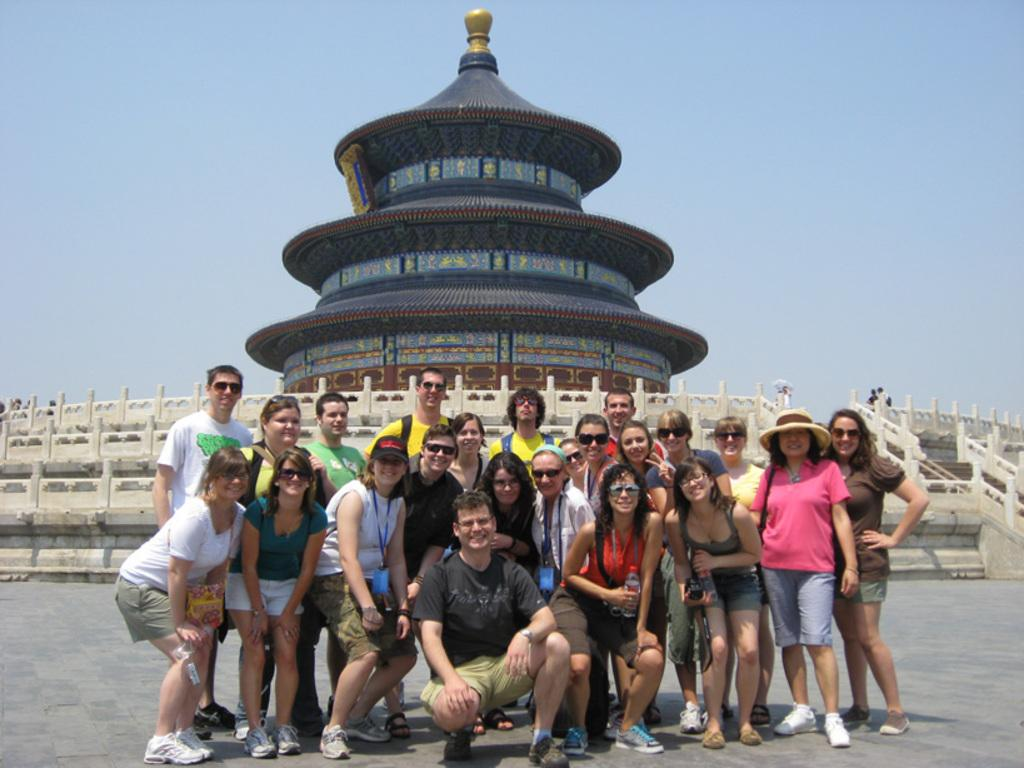What are the people in the image doing? The people in the image are sitting and standing on the floor. What is located behind the people? There is a fence behind the people. What type of structure can be seen in the image? There is a temple visible in the image. What can be seen above the people and the temple? The sky is visible in the image. Can you tell me how many apples are being wished for in the image? There is no mention of apples or wishes in the image; it features people sitting and standing on the floor, a fence, a temple, and the sky. 